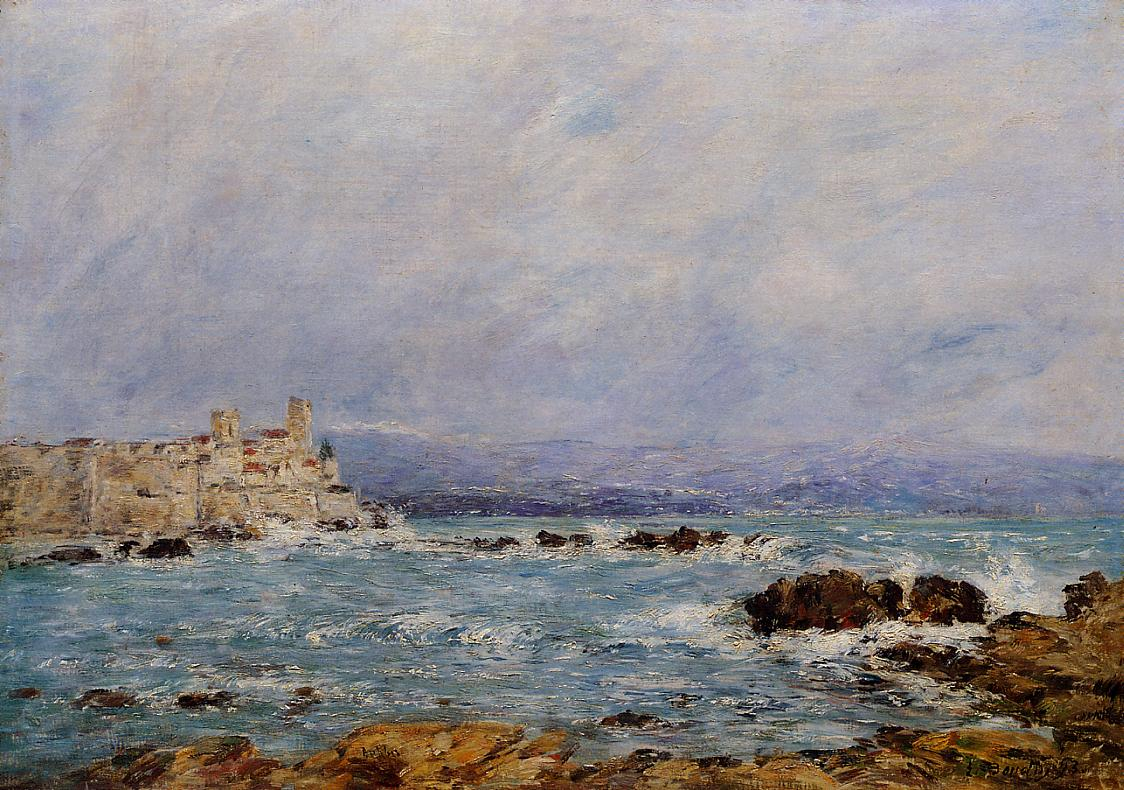If this painting could tell a story, what would it be? Once upon a time, a secluded castle by the sea stood as a fortress for a noble family. The waves eternally kissed the rocky shore, singing ancient ballads of lost sailors and secret treasures hidden within the moss-covered rocks. The castle walls whispered tales of courage, love, and legacy. As generations passed, the castle witnessed both serene days and tempestuous nights, becoming a silent guardian of the coastline. One legend speaks of a hidden passage beneath the castle, leading to a cavern filled with the sparkling treasures of the sea, waiting to be discovered by a daring adventurer. 